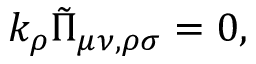Convert formula to latex. <formula><loc_0><loc_0><loc_500><loc_500>k _ { \rho } \tilde { \Pi } _ { \mu \nu , \rho \sigma } = 0 ,</formula> 